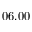<formula> <loc_0><loc_0><loc_500><loc_500>0 6 . 0 0</formula> 